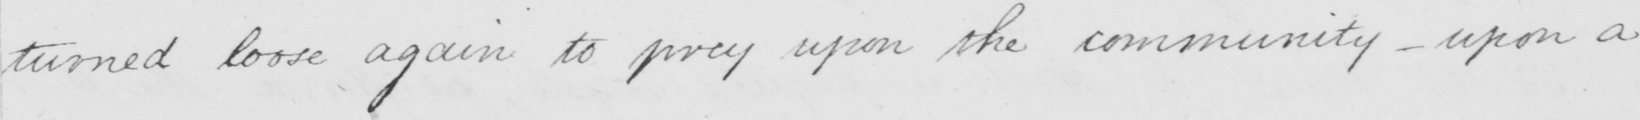Can you tell me what this handwritten text says? turned loose again to prey upon the community  _  upon a 